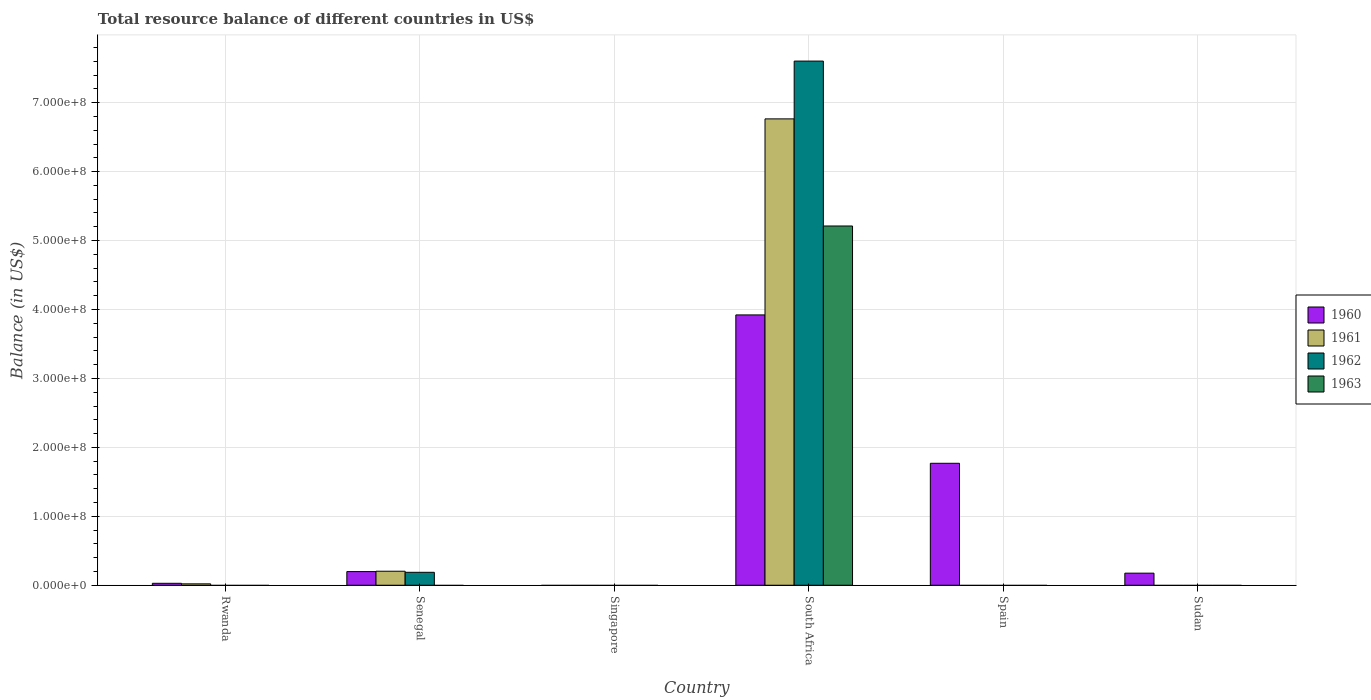How many different coloured bars are there?
Your answer should be very brief. 4. Are the number of bars on each tick of the X-axis equal?
Provide a short and direct response. No. How many bars are there on the 4th tick from the left?
Your answer should be very brief. 4. What is the label of the 5th group of bars from the left?
Give a very brief answer. Spain. In how many cases, is the number of bars for a given country not equal to the number of legend labels?
Offer a very short reply. 5. What is the total resource balance in 1963 in Rwanda?
Give a very brief answer. 0. Across all countries, what is the maximum total resource balance in 1962?
Your answer should be very brief. 7.60e+08. In which country was the total resource balance in 1960 maximum?
Your answer should be compact. South Africa. What is the total total resource balance in 1962 in the graph?
Ensure brevity in your answer.  7.79e+08. What is the difference between the total resource balance in 1960 in Rwanda and that in Spain?
Ensure brevity in your answer.  -1.74e+08. What is the difference between the total resource balance in 1963 in South Africa and the total resource balance in 1961 in Senegal?
Keep it short and to the point. 5.01e+08. What is the average total resource balance in 1962 per country?
Offer a terse response. 1.30e+08. What is the difference between the total resource balance of/in 1961 and total resource balance of/in 1960 in Senegal?
Offer a very short reply. 5.23e+05. What is the ratio of the total resource balance in 1960 in Rwanda to that in Spain?
Make the answer very short. 0.02. What is the difference between the highest and the second highest total resource balance in 1960?
Give a very brief answer. -3.72e+08. What is the difference between the highest and the lowest total resource balance in 1963?
Your answer should be compact. 5.21e+08. Is the sum of the total resource balance in 1960 in South Africa and Sudan greater than the maximum total resource balance in 1962 across all countries?
Your answer should be compact. No. Is it the case that in every country, the sum of the total resource balance in 1962 and total resource balance in 1963 is greater than the total resource balance in 1960?
Your answer should be very brief. No. What is the difference between two consecutive major ticks on the Y-axis?
Offer a very short reply. 1.00e+08. Where does the legend appear in the graph?
Your answer should be very brief. Center right. How many legend labels are there?
Keep it short and to the point. 4. How are the legend labels stacked?
Offer a terse response. Vertical. What is the title of the graph?
Provide a short and direct response. Total resource balance of different countries in US$. What is the label or title of the X-axis?
Provide a short and direct response. Country. What is the label or title of the Y-axis?
Provide a short and direct response. Balance (in US$). What is the Balance (in US$) of 1960 in Rwanda?
Offer a terse response. 2.80e+06. What is the Balance (in US$) in 1961 in Rwanda?
Your answer should be compact. 2.00e+06. What is the Balance (in US$) of 1962 in Rwanda?
Keep it short and to the point. 0. What is the Balance (in US$) of 1960 in Senegal?
Provide a short and direct response. 1.98e+07. What is the Balance (in US$) of 1961 in Senegal?
Give a very brief answer. 2.03e+07. What is the Balance (in US$) of 1962 in Senegal?
Keep it short and to the point. 1.88e+07. What is the Balance (in US$) of 1961 in Singapore?
Keep it short and to the point. 0. What is the Balance (in US$) in 1960 in South Africa?
Offer a terse response. 3.92e+08. What is the Balance (in US$) in 1961 in South Africa?
Provide a short and direct response. 6.77e+08. What is the Balance (in US$) in 1962 in South Africa?
Provide a short and direct response. 7.60e+08. What is the Balance (in US$) of 1963 in South Africa?
Provide a short and direct response. 5.21e+08. What is the Balance (in US$) of 1960 in Spain?
Offer a terse response. 1.77e+08. What is the Balance (in US$) in 1961 in Spain?
Offer a terse response. 0. What is the Balance (in US$) in 1963 in Spain?
Provide a succinct answer. 0. What is the Balance (in US$) in 1960 in Sudan?
Your answer should be compact. 1.75e+07. What is the Balance (in US$) in 1963 in Sudan?
Your answer should be compact. 0. Across all countries, what is the maximum Balance (in US$) of 1960?
Offer a very short reply. 3.92e+08. Across all countries, what is the maximum Balance (in US$) in 1961?
Offer a very short reply. 6.77e+08. Across all countries, what is the maximum Balance (in US$) of 1962?
Keep it short and to the point. 7.60e+08. Across all countries, what is the maximum Balance (in US$) of 1963?
Offer a very short reply. 5.21e+08. Across all countries, what is the minimum Balance (in US$) of 1960?
Your response must be concise. 0. Across all countries, what is the minimum Balance (in US$) in 1961?
Provide a succinct answer. 0. Across all countries, what is the minimum Balance (in US$) of 1962?
Your answer should be very brief. 0. Across all countries, what is the minimum Balance (in US$) in 1963?
Provide a short and direct response. 0. What is the total Balance (in US$) of 1960 in the graph?
Provide a succinct answer. 6.09e+08. What is the total Balance (in US$) in 1961 in the graph?
Give a very brief answer. 6.99e+08. What is the total Balance (in US$) in 1962 in the graph?
Give a very brief answer. 7.79e+08. What is the total Balance (in US$) in 1963 in the graph?
Give a very brief answer. 5.21e+08. What is the difference between the Balance (in US$) of 1960 in Rwanda and that in Senegal?
Offer a very short reply. -1.70e+07. What is the difference between the Balance (in US$) in 1961 in Rwanda and that in Senegal?
Offer a very short reply. -1.83e+07. What is the difference between the Balance (in US$) of 1960 in Rwanda and that in South Africa?
Offer a terse response. -3.89e+08. What is the difference between the Balance (in US$) of 1961 in Rwanda and that in South Africa?
Provide a short and direct response. -6.75e+08. What is the difference between the Balance (in US$) in 1960 in Rwanda and that in Spain?
Make the answer very short. -1.74e+08. What is the difference between the Balance (in US$) of 1960 in Rwanda and that in Sudan?
Offer a terse response. -1.47e+07. What is the difference between the Balance (in US$) of 1960 in Senegal and that in South Africa?
Provide a succinct answer. -3.72e+08. What is the difference between the Balance (in US$) in 1961 in Senegal and that in South Africa?
Keep it short and to the point. -6.56e+08. What is the difference between the Balance (in US$) in 1962 in Senegal and that in South Africa?
Make the answer very short. -7.42e+08. What is the difference between the Balance (in US$) of 1960 in Senegal and that in Spain?
Your answer should be very brief. -1.57e+08. What is the difference between the Balance (in US$) of 1960 in Senegal and that in Sudan?
Offer a terse response. 2.27e+06. What is the difference between the Balance (in US$) of 1960 in South Africa and that in Spain?
Your answer should be compact. 2.15e+08. What is the difference between the Balance (in US$) in 1960 in South Africa and that in Sudan?
Keep it short and to the point. 3.75e+08. What is the difference between the Balance (in US$) in 1960 in Spain and that in Sudan?
Your answer should be very brief. 1.59e+08. What is the difference between the Balance (in US$) in 1960 in Rwanda and the Balance (in US$) in 1961 in Senegal?
Your answer should be very brief. -1.75e+07. What is the difference between the Balance (in US$) in 1960 in Rwanda and the Balance (in US$) in 1962 in Senegal?
Keep it short and to the point. -1.60e+07. What is the difference between the Balance (in US$) in 1961 in Rwanda and the Balance (in US$) in 1962 in Senegal?
Make the answer very short. -1.68e+07. What is the difference between the Balance (in US$) of 1960 in Rwanda and the Balance (in US$) of 1961 in South Africa?
Ensure brevity in your answer.  -6.74e+08. What is the difference between the Balance (in US$) in 1960 in Rwanda and the Balance (in US$) in 1962 in South Africa?
Your response must be concise. -7.58e+08. What is the difference between the Balance (in US$) in 1960 in Rwanda and the Balance (in US$) in 1963 in South Africa?
Make the answer very short. -5.18e+08. What is the difference between the Balance (in US$) in 1961 in Rwanda and the Balance (in US$) in 1962 in South Africa?
Give a very brief answer. -7.58e+08. What is the difference between the Balance (in US$) of 1961 in Rwanda and the Balance (in US$) of 1963 in South Africa?
Offer a very short reply. -5.19e+08. What is the difference between the Balance (in US$) of 1960 in Senegal and the Balance (in US$) of 1961 in South Africa?
Provide a succinct answer. -6.57e+08. What is the difference between the Balance (in US$) in 1960 in Senegal and the Balance (in US$) in 1962 in South Africa?
Ensure brevity in your answer.  -7.41e+08. What is the difference between the Balance (in US$) of 1960 in Senegal and the Balance (in US$) of 1963 in South Africa?
Your answer should be very brief. -5.01e+08. What is the difference between the Balance (in US$) in 1961 in Senegal and the Balance (in US$) in 1962 in South Africa?
Provide a succinct answer. -7.40e+08. What is the difference between the Balance (in US$) in 1961 in Senegal and the Balance (in US$) in 1963 in South Africa?
Offer a terse response. -5.01e+08. What is the difference between the Balance (in US$) in 1962 in Senegal and the Balance (in US$) in 1963 in South Africa?
Ensure brevity in your answer.  -5.02e+08. What is the average Balance (in US$) of 1960 per country?
Make the answer very short. 1.02e+08. What is the average Balance (in US$) in 1961 per country?
Provide a short and direct response. 1.16e+08. What is the average Balance (in US$) in 1962 per country?
Provide a short and direct response. 1.30e+08. What is the average Balance (in US$) in 1963 per country?
Your answer should be very brief. 8.69e+07. What is the difference between the Balance (in US$) in 1960 and Balance (in US$) in 1961 in Rwanda?
Your answer should be very brief. 8.00e+05. What is the difference between the Balance (in US$) in 1960 and Balance (in US$) in 1961 in Senegal?
Make the answer very short. -5.23e+05. What is the difference between the Balance (in US$) in 1960 and Balance (in US$) in 1962 in Senegal?
Offer a very short reply. 1.03e+06. What is the difference between the Balance (in US$) of 1961 and Balance (in US$) of 1962 in Senegal?
Give a very brief answer. 1.55e+06. What is the difference between the Balance (in US$) of 1960 and Balance (in US$) of 1961 in South Africa?
Ensure brevity in your answer.  -2.84e+08. What is the difference between the Balance (in US$) in 1960 and Balance (in US$) in 1962 in South Africa?
Your answer should be very brief. -3.68e+08. What is the difference between the Balance (in US$) in 1960 and Balance (in US$) in 1963 in South Africa?
Offer a terse response. -1.29e+08. What is the difference between the Balance (in US$) in 1961 and Balance (in US$) in 1962 in South Africa?
Your answer should be very brief. -8.38e+07. What is the difference between the Balance (in US$) of 1961 and Balance (in US$) of 1963 in South Africa?
Your answer should be compact. 1.55e+08. What is the difference between the Balance (in US$) in 1962 and Balance (in US$) in 1963 in South Africa?
Provide a succinct answer. 2.39e+08. What is the ratio of the Balance (in US$) in 1960 in Rwanda to that in Senegal?
Offer a terse response. 0.14. What is the ratio of the Balance (in US$) of 1961 in Rwanda to that in Senegal?
Ensure brevity in your answer.  0.1. What is the ratio of the Balance (in US$) of 1960 in Rwanda to that in South Africa?
Ensure brevity in your answer.  0.01. What is the ratio of the Balance (in US$) of 1961 in Rwanda to that in South Africa?
Make the answer very short. 0. What is the ratio of the Balance (in US$) of 1960 in Rwanda to that in Spain?
Your answer should be compact. 0.02. What is the ratio of the Balance (in US$) of 1960 in Rwanda to that in Sudan?
Your answer should be compact. 0.16. What is the ratio of the Balance (in US$) in 1960 in Senegal to that in South Africa?
Your response must be concise. 0.05. What is the ratio of the Balance (in US$) of 1961 in Senegal to that in South Africa?
Offer a terse response. 0.03. What is the ratio of the Balance (in US$) of 1962 in Senegal to that in South Africa?
Make the answer very short. 0.02. What is the ratio of the Balance (in US$) of 1960 in Senegal to that in Spain?
Make the answer very short. 0.11. What is the ratio of the Balance (in US$) of 1960 in Senegal to that in Sudan?
Keep it short and to the point. 1.13. What is the ratio of the Balance (in US$) of 1960 in South Africa to that in Spain?
Offer a very short reply. 2.22. What is the ratio of the Balance (in US$) in 1960 in South Africa to that in Sudan?
Your answer should be compact. 22.38. What is the ratio of the Balance (in US$) in 1960 in Spain to that in Sudan?
Make the answer very short. 10.1. What is the difference between the highest and the second highest Balance (in US$) in 1960?
Your response must be concise. 2.15e+08. What is the difference between the highest and the second highest Balance (in US$) of 1961?
Your answer should be very brief. 6.56e+08. What is the difference between the highest and the lowest Balance (in US$) in 1960?
Your answer should be very brief. 3.92e+08. What is the difference between the highest and the lowest Balance (in US$) of 1961?
Provide a succinct answer. 6.77e+08. What is the difference between the highest and the lowest Balance (in US$) in 1962?
Your answer should be compact. 7.60e+08. What is the difference between the highest and the lowest Balance (in US$) of 1963?
Ensure brevity in your answer.  5.21e+08. 